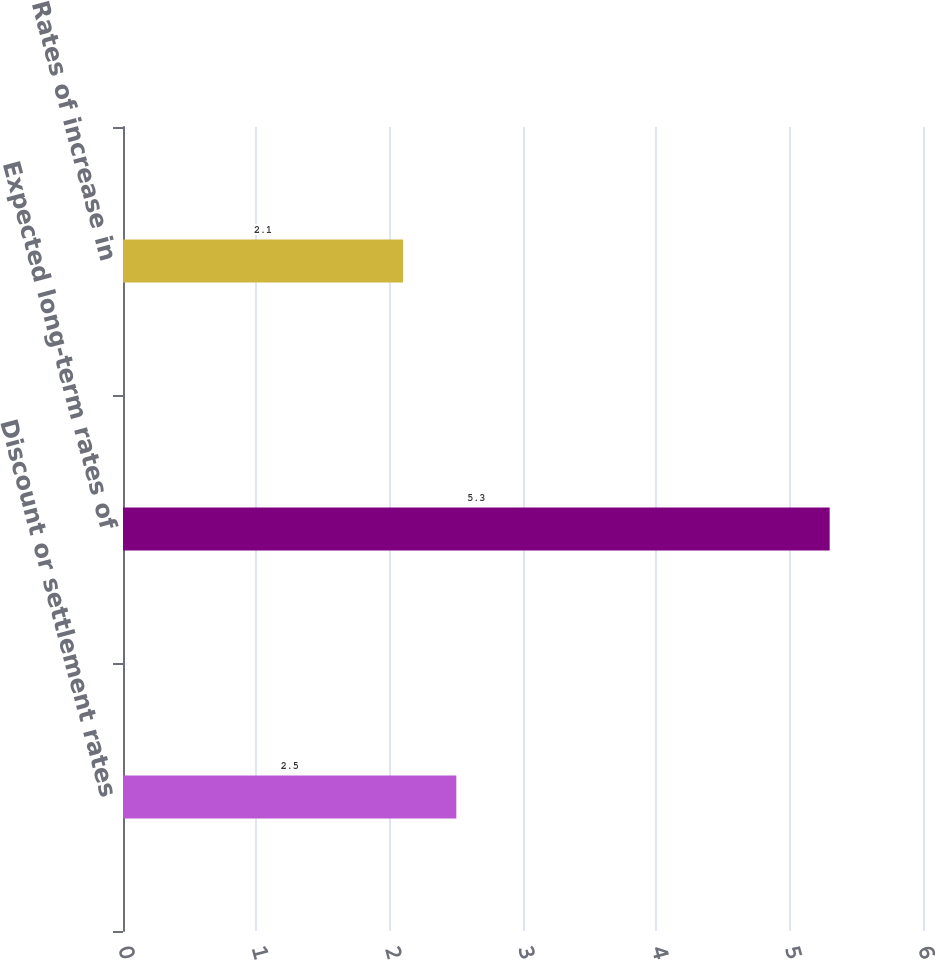<chart> <loc_0><loc_0><loc_500><loc_500><bar_chart><fcel>Discount or settlement rates<fcel>Expected long-term rates of<fcel>Rates of increase in<nl><fcel>2.5<fcel>5.3<fcel>2.1<nl></chart> 